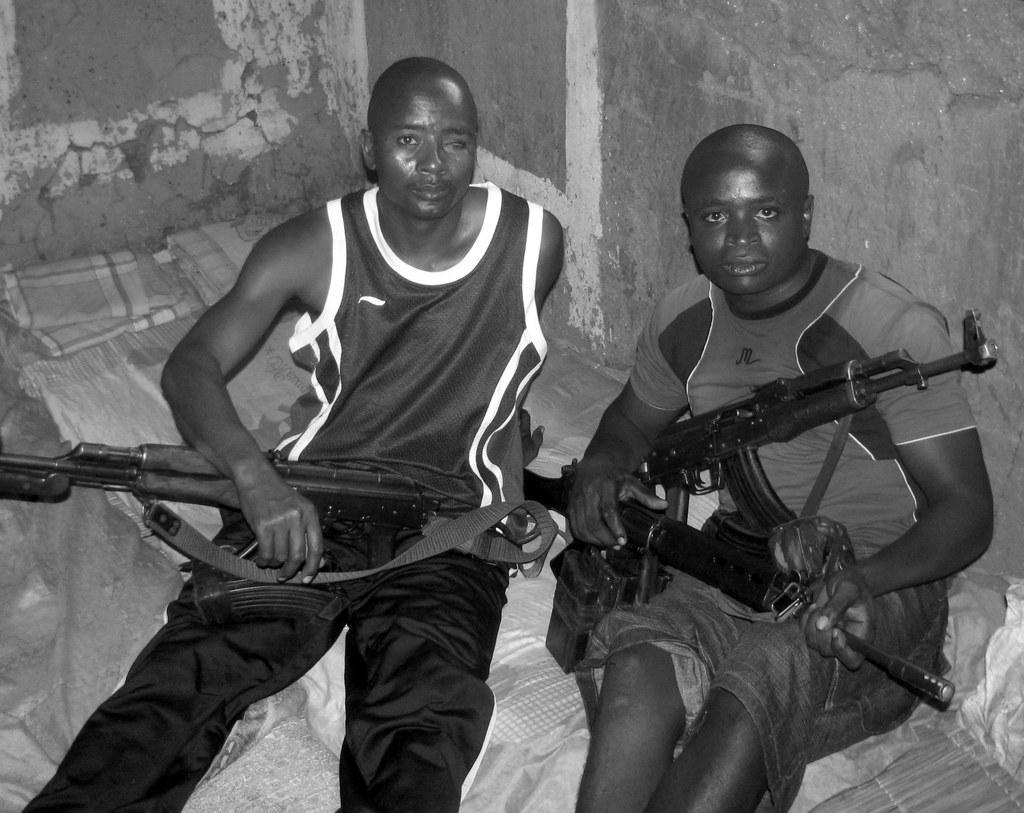Could you give a brief overview of what you see in this image? In this image we can see two persons sitting down and holding guns in their hands. We can see blankets and wall in the background. 